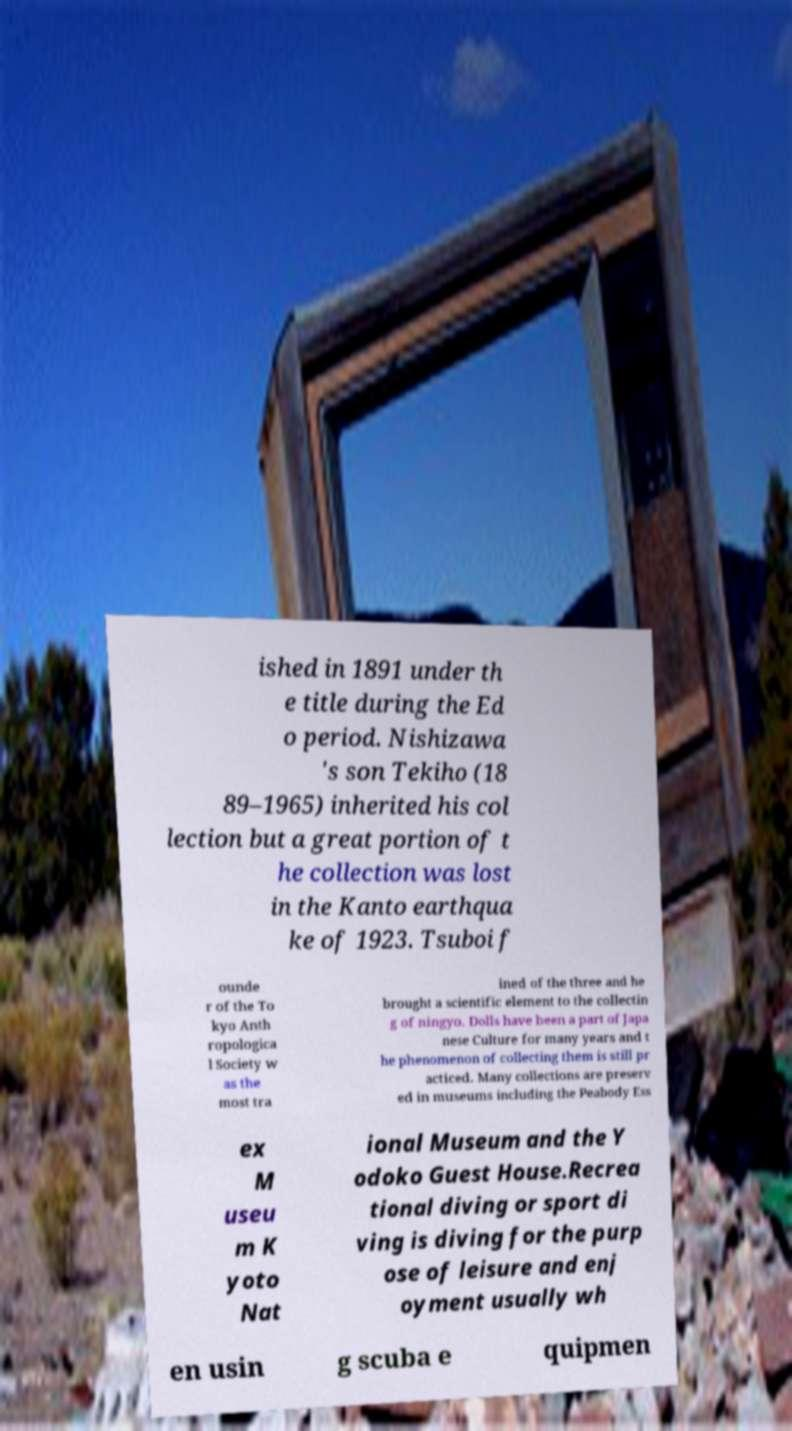Could you assist in decoding the text presented in this image and type it out clearly? ished in 1891 under th e title during the Ed o period. Nishizawa 's son Tekiho (18 89–1965) inherited his col lection but a great portion of t he collection was lost in the Kanto earthqua ke of 1923. Tsuboi f ounde r of the To kyo Anth ropologica l Society w as the most tra ined of the three and he brought a scientific element to the collectin g of ningyo. Dolls have been a part of Japa nese Culture for many years and t he phenomenon of collecting them is still pr acticed. Many collections are preserv ed in museums including the Peabody Ess ex M useu m K yoto Nat ional Museum and the Y odoko Guest House.Recrea tional diving or sport di ving is diving for the purp ose of leisure and enj oyment usually wh en usin g scuba e quipmen 